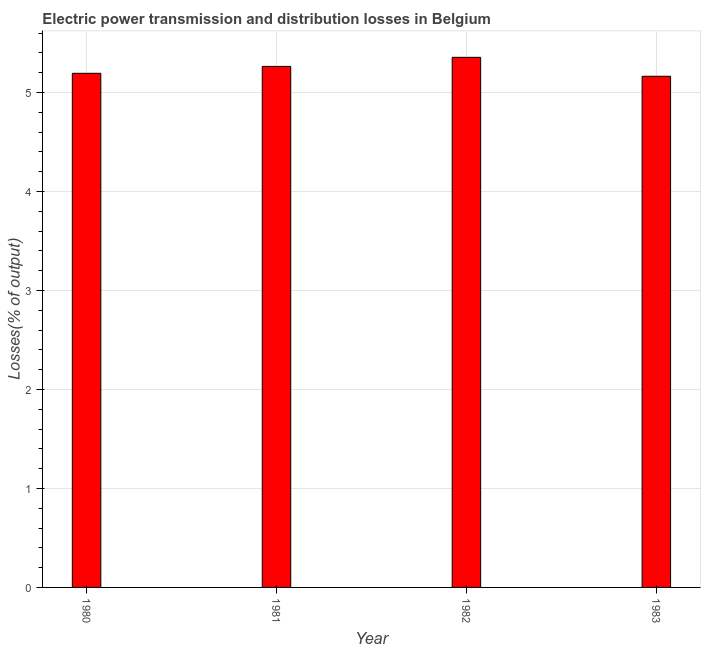Does the graph contain any zero values?
Make the answer very short. No. What is the title of the graph?
Keep it short and to the point. Electric power transmission and distribution losses in Belgium. What is the label or title of the X-axis?
Offer a very short reply. Year. What is the label or title of the Y-axis?
Your response must be concise. Losses(% of output). What is the electric power transmission and distribution losses in 1982?
Ensure brevity in your answer.  5.35. Across all years, what is the maximum electric power transmission and distribution losses?
Offer a terse response. 5.35. Across all years, what is the minimum electric power transmission and distribution losses?
Ensure brevity in your answer.  5.16. In which year was the electric power transmission and distribution losses maximum?
Your answer should be compact. 1982. In which year was the electric power transmission and distribution losses minimum?
Provide a short and direct response. 1983. What is the sum of the electric power transmission and distribution losses?
Ensure brevity in your answer.  20.97. What is the difference between the electric power transmission and distribution losses in 1982 and 1983?
Your response must be concise. 0.19. What is the average electric power transmission and distribution losses per year?
Give a very brief answer. 5.24. What is the median electric power transmission and distribution losses?
Make the answer very short. 5.23. Is the difference between the electric power transmission and distribution losses in 1980 and 1981 greater than the difference between any two years?
Keep it short and to the point. No. What is the difference between the highest and the second highest electric power transmission and distribution losses?
Keep it short and to the point. 0.09. Is the sum of the electric power transmission and distribution losses in 1980 and 1982 greater than the maximum electric power transmission and distribution losses across all years?
Your answer should be very brief. Yes. What is the difference between the highest and the lowest electric power transmission and distribution losses?
Offer a terse response. 0.19. In how many years, is the electric power transmission and distribution losses greater than the average electric power transmission and distribution losses taken over all years?
Keep it short and to the point. 2. Are all the bars in the graph horizontal?
Provide a succinct answer. No. How many years are there in the graph?
Provide a succinct answer. 4. What is the Losses(% of output) in 1980?
Provide a succinct answer. 5.19. What is the Losses(% of output) in 1981?
Ensure brevity in your answer.  5.26. What is the Losses(% of output) of 1982?
Give a very brief answer. 5.35. What is the Losses(% of output) in 1983?
Offer a terse response. 5.16. What is the difference between the Losses(% of output) in 1980 and 1981?
Your answer should be compact. -0.07. What is the difference between the Losses(% of output) in 1980 and 1982?
Provide a short and direct response. -0.16. What is the difference between the Losses(% of output) in 1980 and 1983?
Your answer should be very brief. 0.03. What is the difference between the Losses(% of output) in 1981 and 1982?
Your answer should be very brief. -0.09. What is the difference between the Losses(% of output) in 1981 and 1983?
Make the answer very short. 0.1. What is the difference between the Losses(% of output) in 1982 and 1983?
Your answer should be compact. 0.19. What is the ratio of the Losses(% of output) in 1981 to that in 1982?
Offer a very short reply. 0.98. 